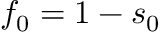<formula> <loc_0><loc_0><loc_500><loc_500>f _ { 0 } = 1 - s _ { 0 }</formula> 